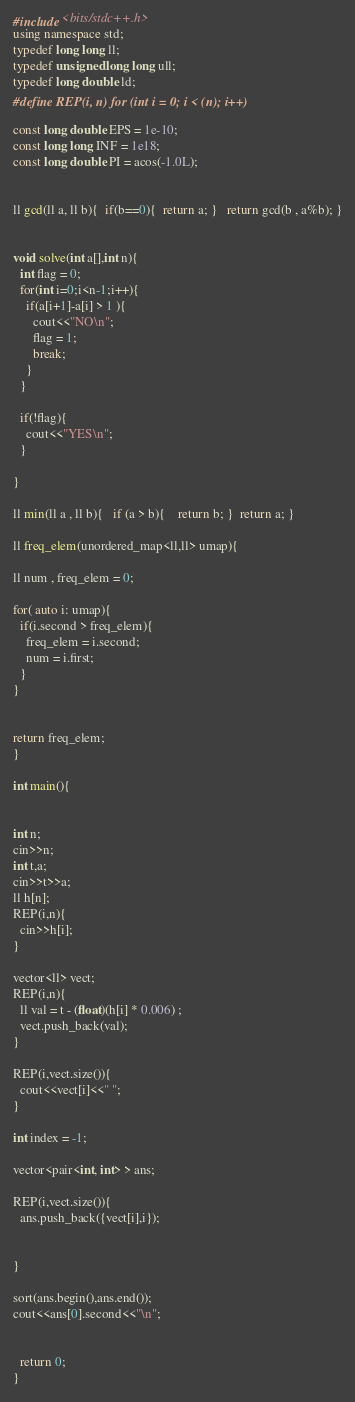Convert code to text. <code><loc_0><loc_0><loc_500><loc_500><_C++_>#include <bits/stdc++.h>
using namespace std;
typedef long long ll;
typedef unsigned long long ull;
typedef long double ld;
#define REP(i, n) for (int i = 0; i < (n); i++)

const long double EPS = 1e-10;
const long long INF = 1e18;
const long double PI = acos(-1.0L);


ll gcd(ll a, ll b){  if(b==0){  return a; }   return gcd(b , a%b); }


void solve(int a[],int n){
  int flag = 0;
  for(int i=0;i<n-1;i++){
    if(a[i+1]-a[i] > 1 ){
      cout<<"NO\n";
      flag = 1;
      break;
    }
  }

  if(!flag){
    cout<<"YES\n";
  }
  
}

ll min(ll a , ll b){   if (a > b){    return b; }  return a; }

ll freq_elem(unordered_map<ll,ll> umap){

ll num , freq_elem = 0;

for( auto i: umap){
  if(i.second > freq_elem){
    freq_elem = i.second;
    num = i.first;
  }
}


return freq_elem;
}

int main(){


int n;
cin>>n;
int t,a;
cin>>t>>a;
ll h[n];
REP(i,n){
  cin>>h[i];
}

vector<ll> vect;
REP(i,n){
  ll val = t - (float)(h[i] * 0.006) ; 
  vect.push_back(val);
}

REP(i,vect.size()){
  cout<<vect[i]<<" ";
}

int index = -1;

vector<pair<int, int> > ans;

REP(i,vect.size()){
  ans.push_back({vect[i],i});


}

sort(ans.begin(),ans.end());
cout<<ans[0].second<<"\n";


  return 0;
}


</code> 